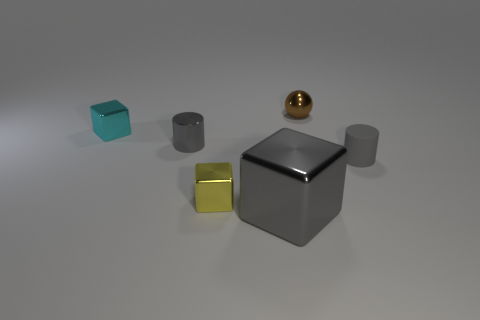What number of things are either cyan cubes or tiny blocks?
Provide a succinct answer. 2. What material is the other cylinder that is the same color as the tiny metal cylinder?
Offer a terse response. Rubber. Is there a yellow object that has the same shape as the tiny gray matte object?
Make the answer very short. No. There is a gray matte object; how many big gray things are behind it?
Offer a terse response. 0. There is a tiny cylinder that is to the left of the gray cylinder right of the metallic cylinder; what is it made of?
Your answer should be compact. Metal. There is a sphere that is the same size as the yellow shiny thing; what is its material?
Ensure brevity in your answer.  Metal. Is there a cyan metal cube of the same size as the yellow cube?
Give a very brief answer. Yes. What is the color of the object that is to the right of the small brown object?
Offer a terse response. Gray. There is a tiny cylinder that is on the left side of the gray metallic cube; is there a yellow metal object in front of it?
Your answer should be compact. Yes. How many other objects are the same color as the big metal thing?
Ensure brevity in your answer.  2. 